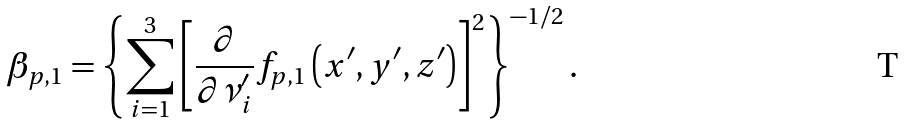<formula> <loc_0><loc_0><loc_500><loc_500>\beta _ { p , 1 } & = \left \{ \sum _ { i = 1 } ^ { 3 } \left [ \frac { \partial } { \partial \nu ^ { \prime } _ { i } } f _ { p , 1 } \left ( x ^ { \prime } , y ^ { \prime } , z ^ { \prime } \right ) \right ] ^ { 2 } \right \} ^ { - 1 / 2 } .</formula> 